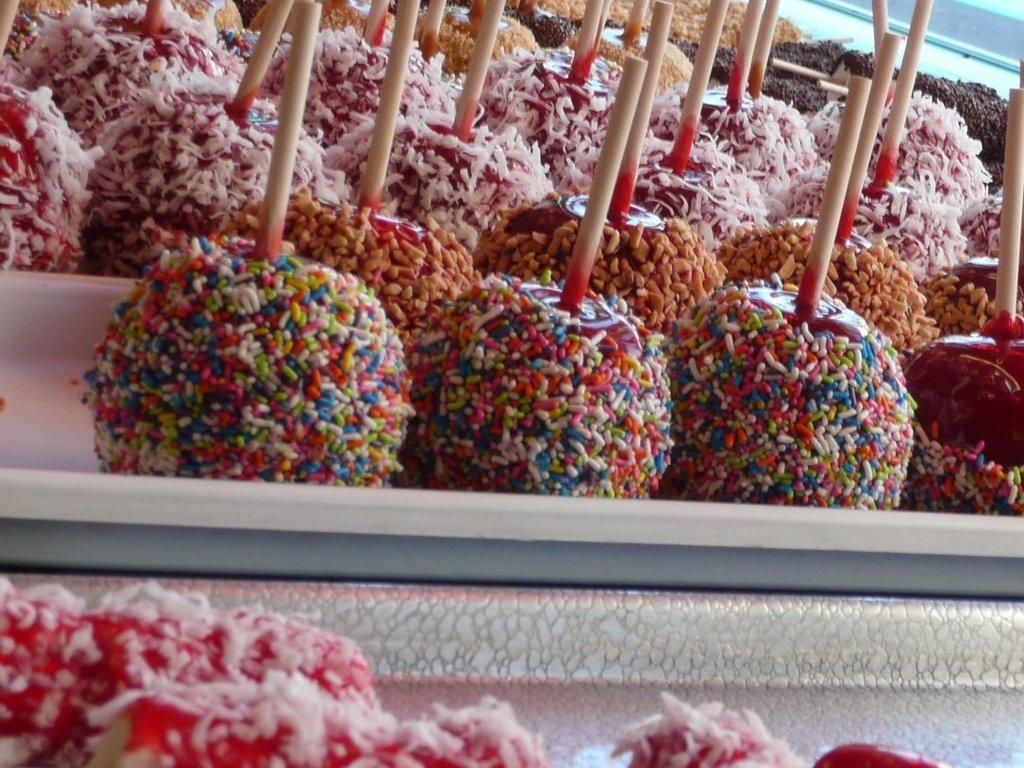What types of items are present in the image? There are food items in the image. Can you describe the appearance of the food items? The food items are in multiple colors. What is the color of the surface on which the food items are placed? The food items are on a white surface. How many structures can be seen in the image? There is no structure present in the image; it only features food items on a white surface. 